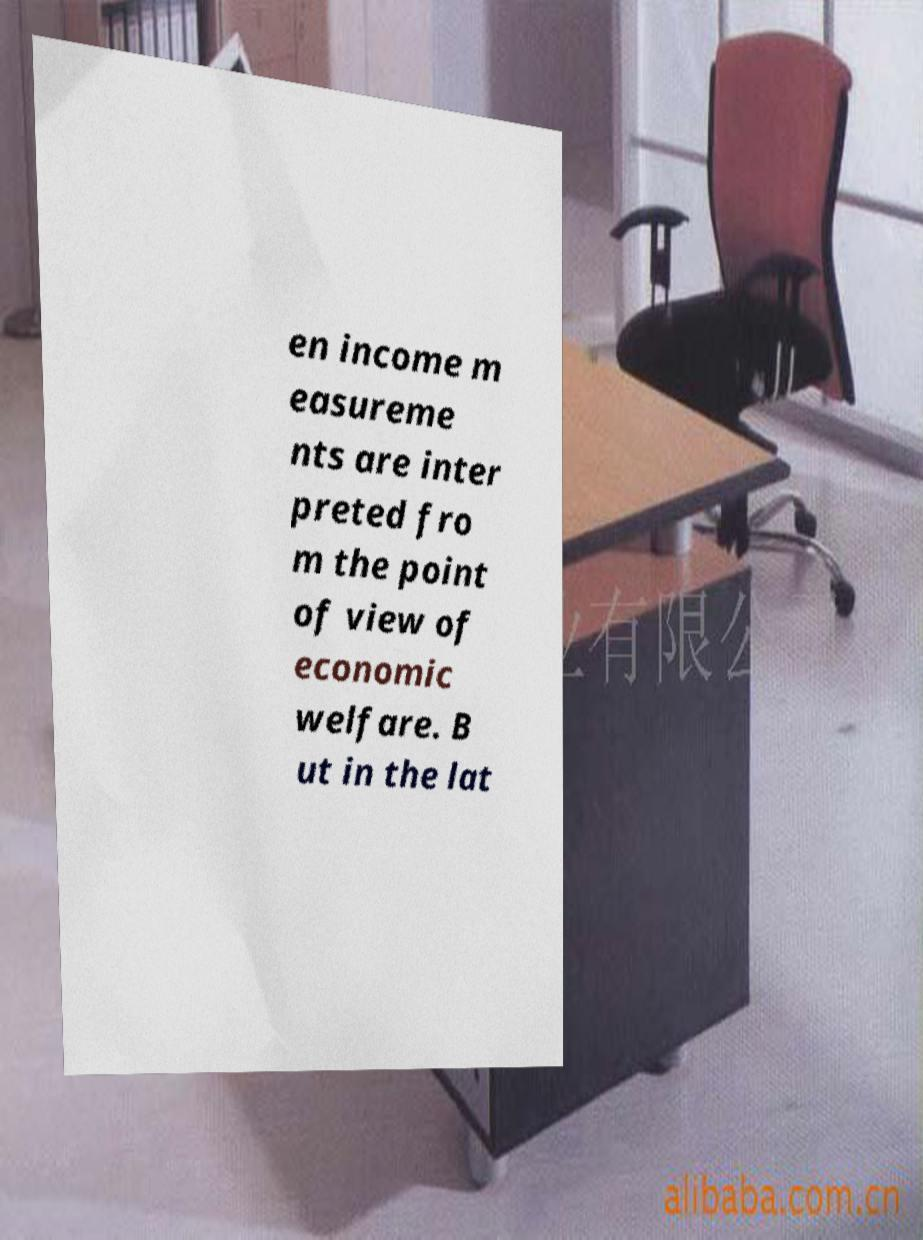Can you read and provide the text displayed in the image?This photo seems to have some interesting text. Can you extract and type it out for me? en income m easureme nts are inter preted fro m the point of view of economic welfare. B ut in the lat 